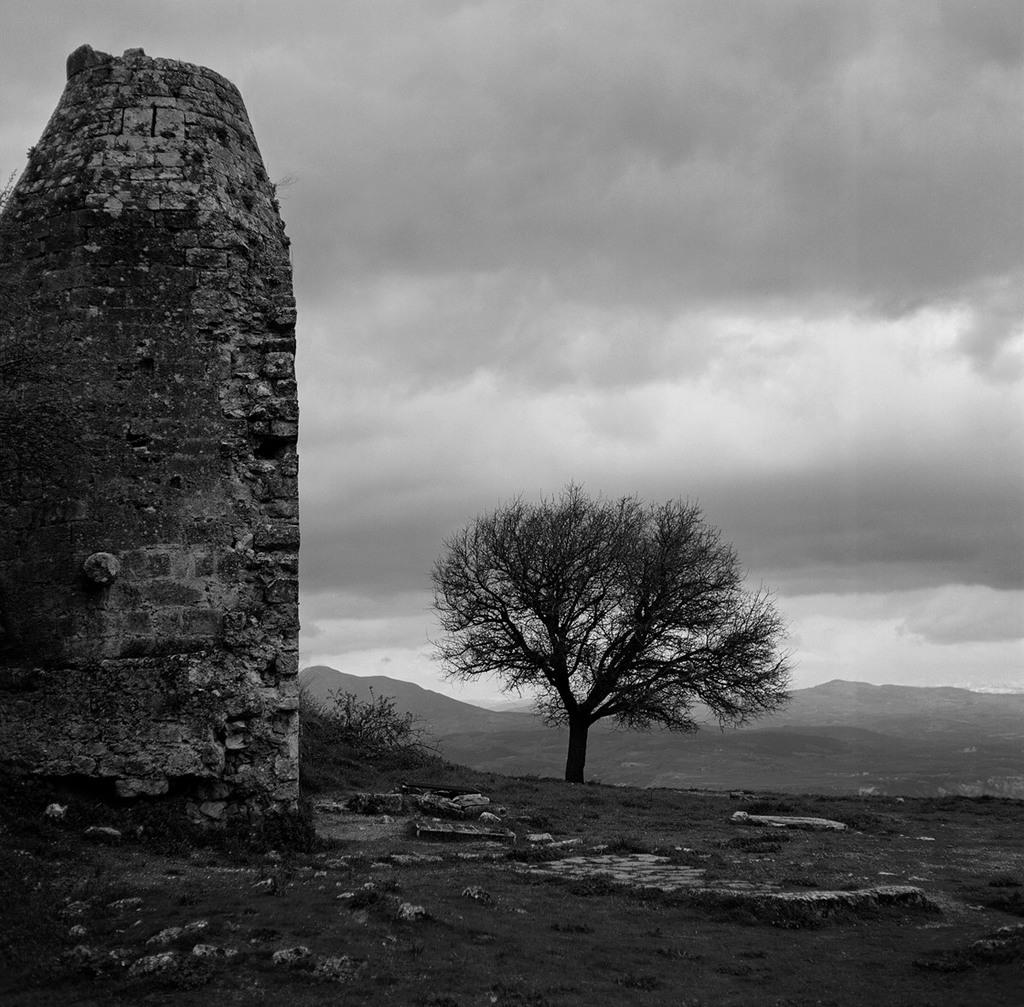What structure is located on the left side of the image? There is a wall on the left side of the image. What can be seen in the middle of the image? There are trees and hills in the middle of the image. What is visible at the top of the image? The sky is visible at the top of the image. What is the weight of the ice on the wall in the image? There is no ice on the wall in the image, so it is not possible to determine its weight. 